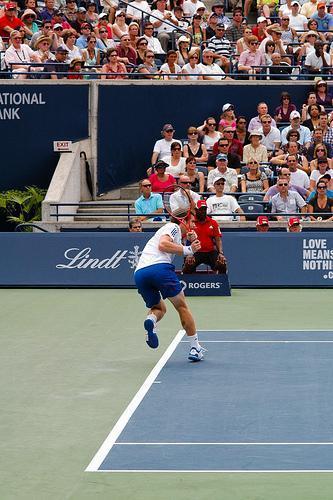How many tennis players are in the picture?
Give a very brief answer. 1. 